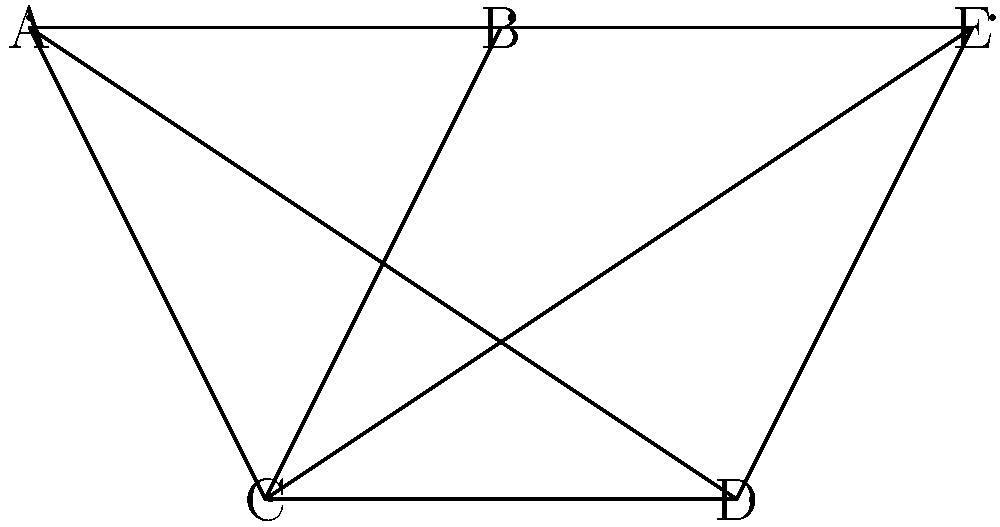As an extreme sports tournament organizer, you need to schedule five events: A (Wingsuit Flying), B (Cliff Diving), C (Ice Climbing), D (Volcano Boarding), and E (Cave Diving). Due to safety concerns and equipment limitations, some events cannot be scheduled simultaneously. The graph represents the conflicts, where connected events cannot occur at the same time. What is the minimum number of time slots needed to schedule all events without conflicts? To solve this problem, we need to use graph coloring:

1. Each node represents an event, and edges represent conflicts between events.
2. The minimum number of colors needed to color the graph (chromatic number) equals the minimum number of time slots required.

Let's color the graph step by step:

1. Start with event A. Color it with color 1.
2. B is connected to A, so it needs a new color. Color B with color 2.
3. C is connected to A and B. It needs a new color. Color C with color 3.
4. D is connected to A and C. It can use color 2 (same as B).
5. E is connected to B and C. It can use color 1 (same as A).

We used 3 colors in total, which means we need a minimum of 3 time slots to schedule all events without conflicts.

This coloring is optimal because:
- A, B, and C form a triangle, requiring at least 3 colors.
- No other node requires a 4th color.

Therefore, the chromatic number of this graph is 3.
Answer: 3 time slots 